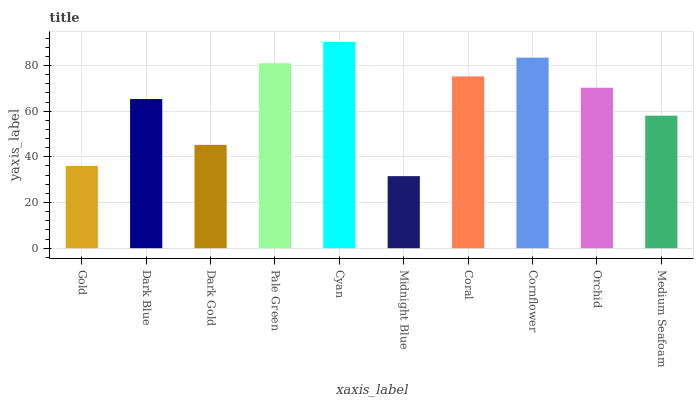Is Midnight Blue the minimum?
Answer yes or no. Yes. Is Cyan the maximum?
Answer yes or no. Yes. Is Dark Blue the minimum?
Answer yes or no. No. Is Dark Blue the maximum?
Answer yes or no. No. Is Dark Blue greater than Gold?
Answer yes or no. Yes. Is Gold less than Dark Blue?
Answer yes or no. Yes. Is Gold greater than Dark Blue?
Answer yes or no. No. Is Dark Blue less than Gold?
Answer yes or no. No. Is Orchid the high median?
Answer yes or no. Yes. Is Dark Blue the low median?
Answer yes or no. Yes. Is Pale Green the high median?
Answer yes or no. No. Is Pale Green the low median?
Answer yes or no. No. 